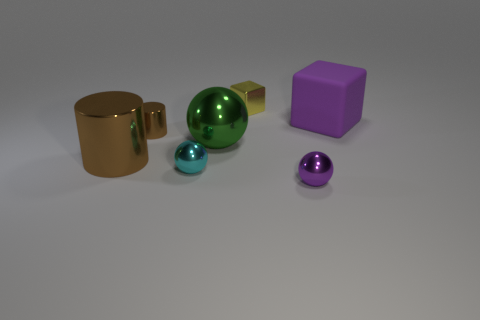Add 1 brown matte cylinders. How many objects exist? 8 Subtract all cylinders. How many objects are left? 5 Subtract 0 brown blocks. How many objects are left? 7 Subtract all purple metal spheres. Subtract all purple shiny things. How many objects are left? 5 Add 3 purple matte objects. How many purple matte objects are left? 4 Add 4 big brown metallic cylinders. How many big brown metallic cylinders exist? 5 